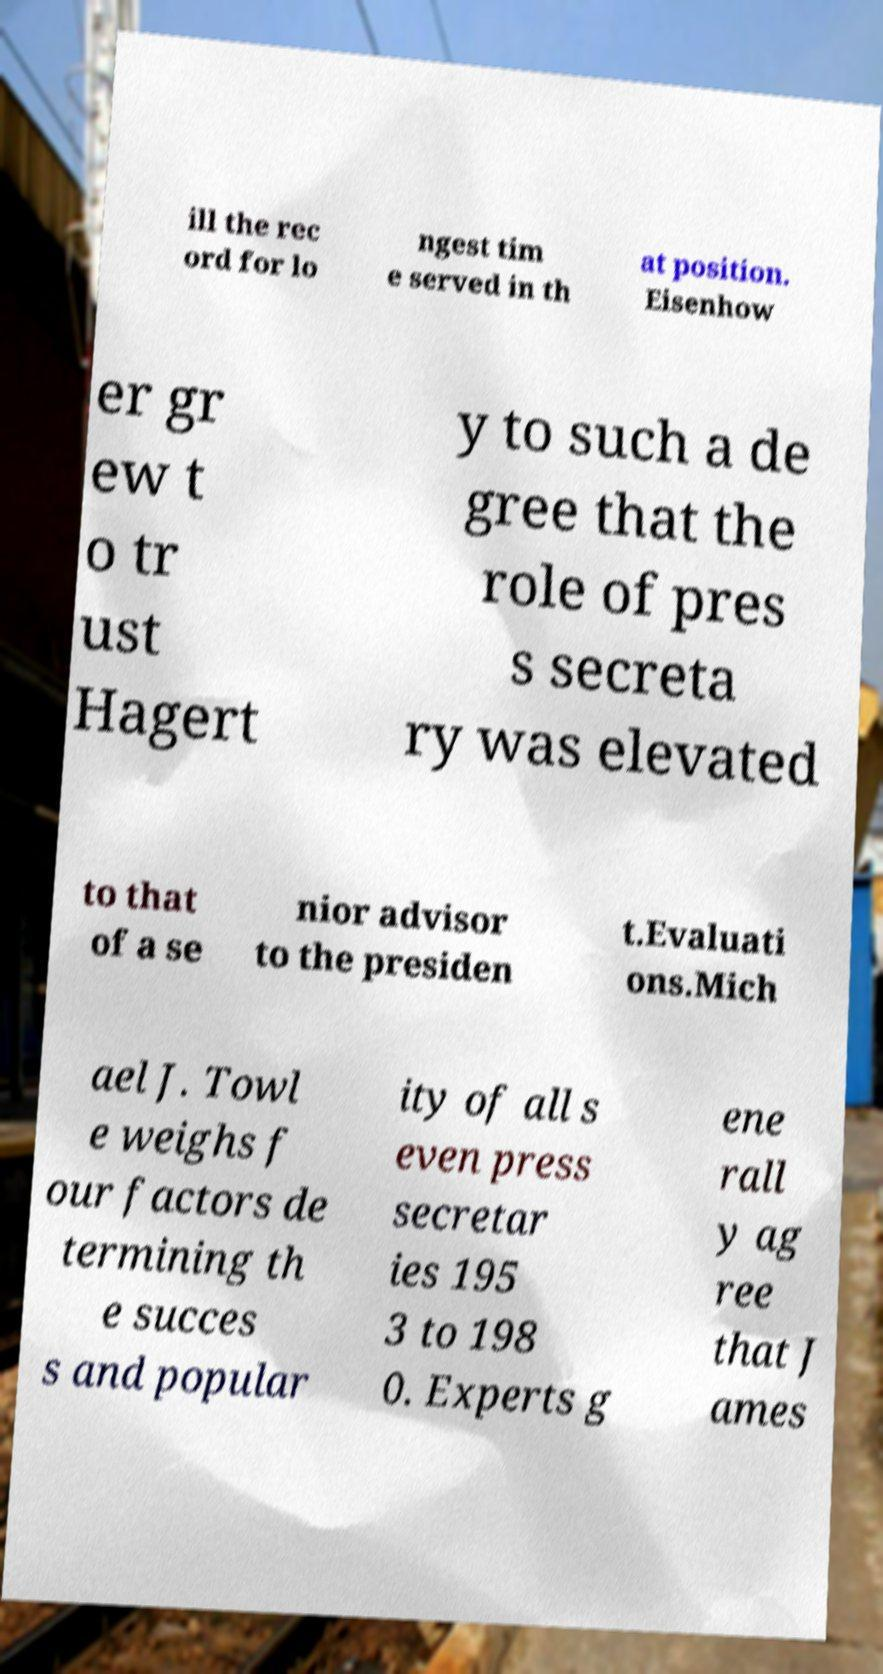Could you extract and type out the text from this image? ill the rec ord for lo ngest tim e served in th at position. Eisenhow er gr ew t o tr ust Hagert y to such a de gree that the role of pres s secreta ry was elevated to that of a se nior advisor to the presiden t.Evaluati ons.Mich ael J. Towl e weighs f our factors de termining th e succes s and popular ity of all s even press secretar ies 195 3 to 198 0. Experts g ene rall y ag ree that J ames 